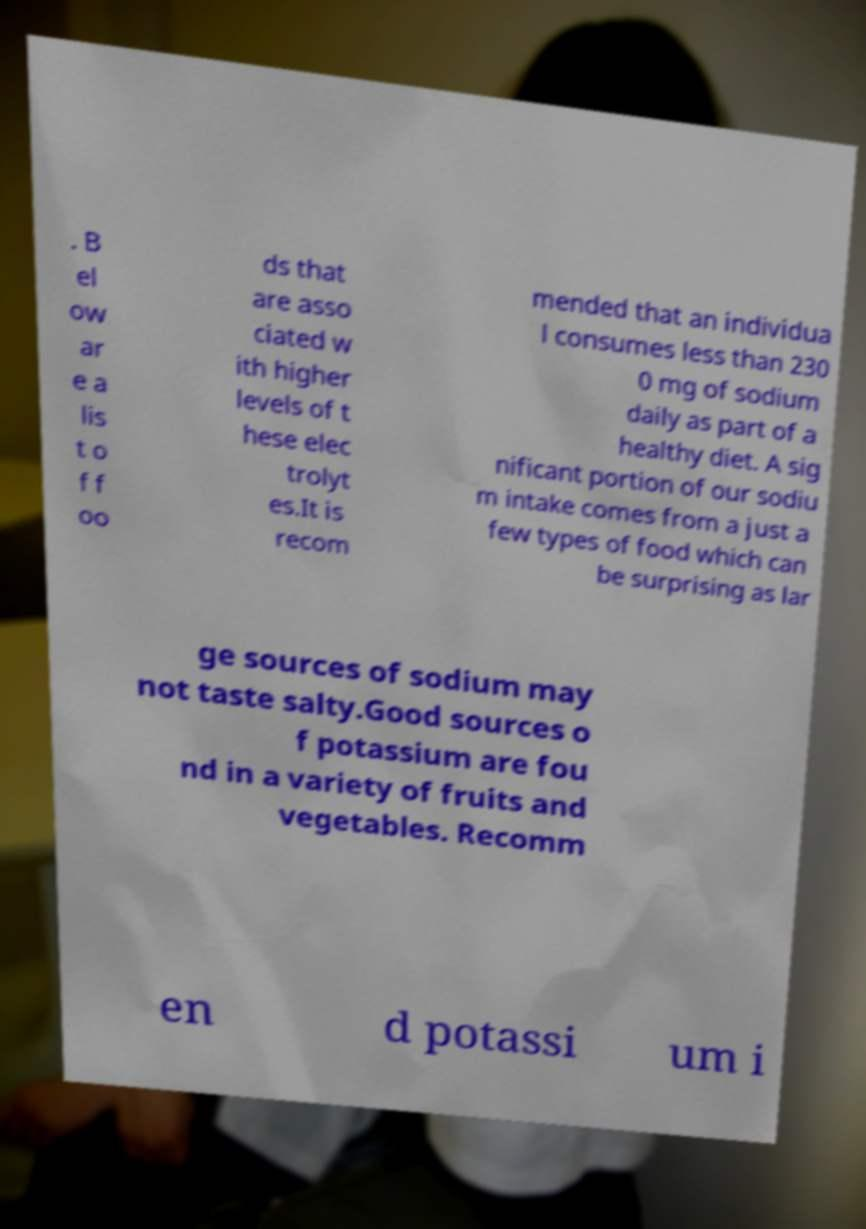Could you assist in decoding the text presented in this image and type it out clearly? . B el ow ar e a lis t o f f oo ds that are asso ciated w ith higher levels of t hese elec trolyt es.It is recom mended that an individua l consumes less than 230 0 mg of sodium daily as part of a healthy diet. A sig nificant portion of our sodiu m intake comes from a just a few types of food which can be surprising as lar ge sources of sodium may not taste salty.Good sources o f potassium are fou nd in a variety of fruits and vegetables. Recomm en d potassi um i 